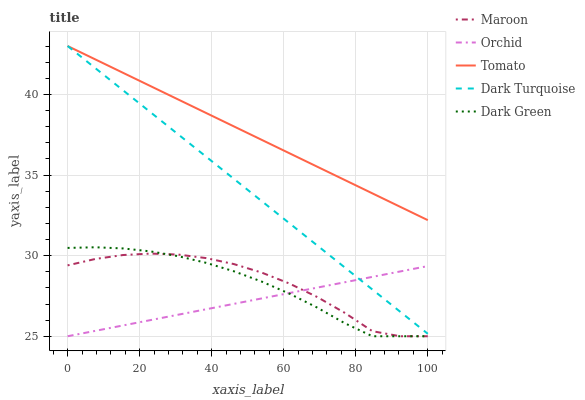Does Orchid have the minimum area under the curve?
Answer yes or no. Yes. Does Tomato have the maximum area under the curve?
Answer yes or no. Yes. Does Dark Turquoise have the minimum area under the curve?
Answer yes or no. No. Does Dark Turquoise have the maximum area under the curve?
Answer yes or no. No. Is Orchid the smoothest?
Answer yes or no. Yes. Is Maroon the roughest?
Answer yes or no. Yes. Is Dark Turquoise the smoothest?
Answer yes or no. No. Is Dark Turquoise the roughest?
Answer yes or no. No. Does Dark Green have the lowest value?
Answer yes or no. Yes. Does Dark Turquoise have the lowest value?
Answer yes or no. No. Does Dark Turquoise have the highest value?
Answer yes or no. Yes. Does Dark Green have the highest value?
Answer yes or no. No. Is Maroon less than Dark Turquoise?
Answer yes or no. Yes. Is Tomato greater than Orchid?
Answer yes or no. Yes. Does Orchid intersect Maroon?
Answer yes or no. Yes. Is Orchid less than Maroon?
Answer yes or no. No. Is Orchid greater than Maroon?
Answer yes or no. No. Does Maroon intersect Dark Turquoise?
Answer yes or no. No. 